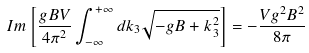Convert formula to latex. <formula><loc_0><loc_0><loc_500><loc_500>I m \left [ \frac { g B V } { 4 \pi ^ { 2 } } \int _ { - \infty } ^ { + \infty } d k _ { 3 } \sqrt { - g B + k _ { 3 } ^ { 2 } } \right ] = - \frac { V g ^ { 2 } B ^ { 2 } } { 8 \pi }</formula> 